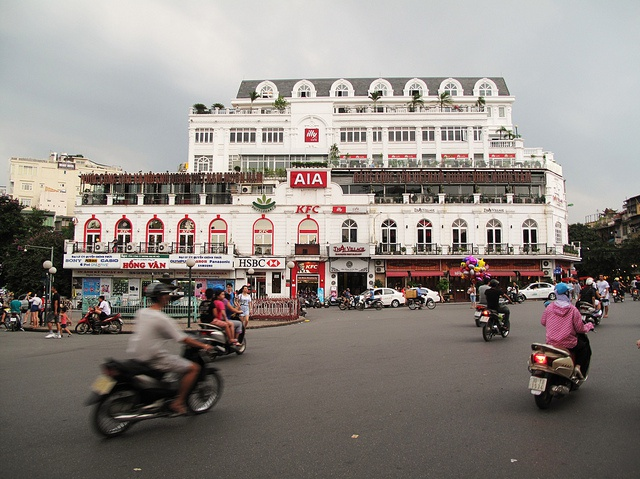Describe the objects in this image and their specific colors. I can see motorcycle in lightgray, black, and gray tones, people in lightgray, black, gray, and darkgray tones, motorcycle in lightgray, black, maroon, and gray tones, people in lightgray, black, gray, brown, and maroon tones, and people in lightgray, brown, black, violet, and maroon tones in this image. 